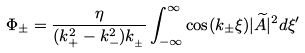Convert formula to latex. <formula><loc_0><loc_0><loc_500><loc_500>\Phi _ { \pm } = \frac { \eta } { ( k _ { + } ^ { 2 } - k _ { - } ^ { 2 } ) k _ { _ { \pm } } } \int _ { - \infty } ^ { \infty } \cos ( k _ { \pm } \xi ) | \widetilde { A } | ^ { 2 } d \xi ^ { \prime }</formula> 